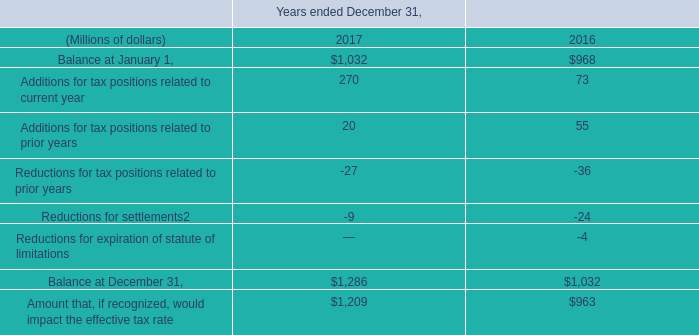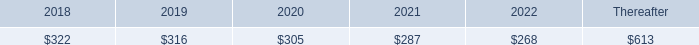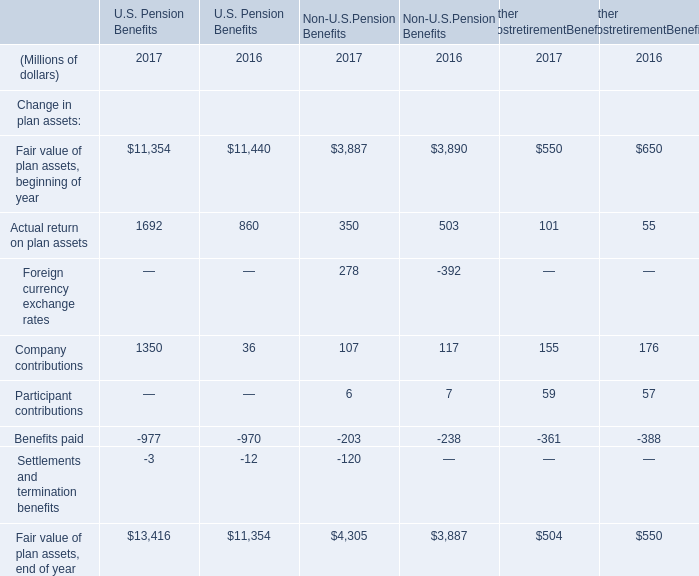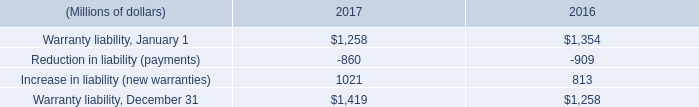what was pre impairment goodwill in millions for surface mining & technology as of october 1 , 2016? 
Computations: (595 + 629)
Answer: 1224.0. 